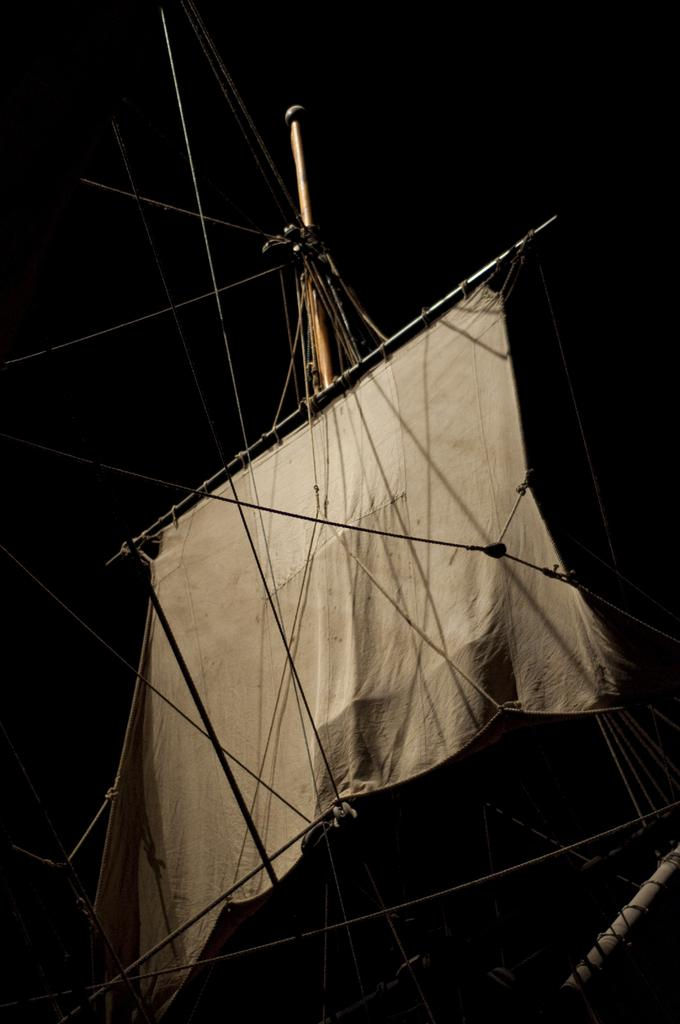What material is present in the image? There is cloth in the image. What object is visible in the image that could be used for support or hanging? There is a rod in the image. What type of flexible material is present in the image? There are ropes in the image. How would you describe the lighting in the image? The background of the image is dark. Who is the owner of the magic rate in the image? There is no mention of an owner, magic, or rate in the image. The image only contains cloth, a rod, and ropes, with a dark background. 